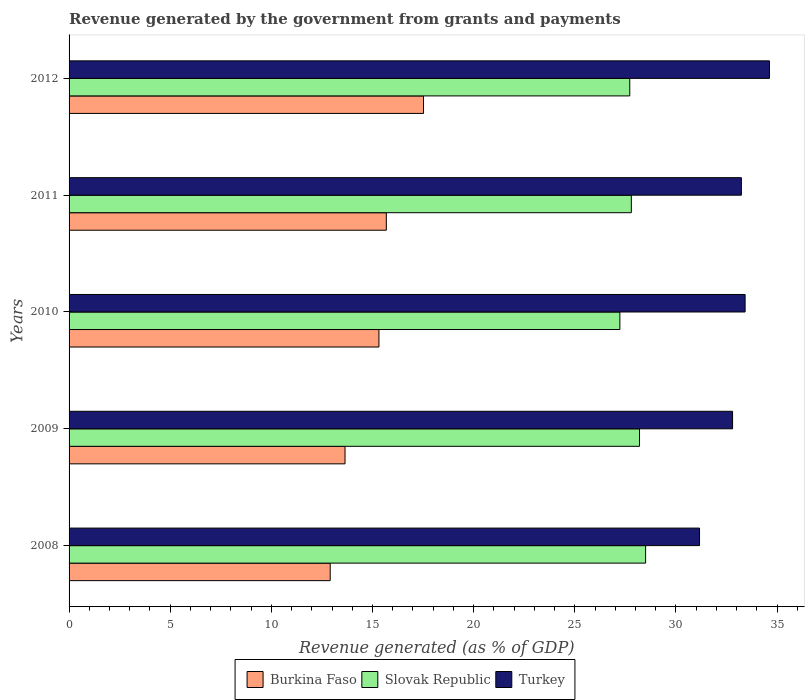How many different coloured bars are there?
Your response must be concise. 3. How many groups of bars are there?
Your answer should be compact. 5. How many bars are there on the 4th tick from the top?
Provide a succinct answer. 3. What is the label of the 4th group of bars from the top?
Your answer should be compact. 2009. In how many cases, is the number of bars for a given year not equal to the number of legend labels?
Offer a terse response. 0. What is the revenue generated by the government in Burkina Faso in 2011?
Make the answer very short. 15.68. Across all years, what is the maximum revenue generated by the government in Slovak Republic?
Offer a very short reply. 28.5. Across all years, what is the minimum revenue generated by the government in Burkina Faso?
Give a very brief answer. 12.91. In which year was the revenue generated by the government in Turkey minimum?
Make the answer very short. 2008. What is the total revenue generated by the government in Slovak Republic in the graph?
Your response must be concise. 139.44. What is the difference between the revenue generated by the government in Slovak Republic in 2008 and that in 2012?
Provide a short and direct response. 0.78. What is the difference between the revenue generated by the government in Burkina Faso in 2008 and the revenue generated by the government in Turkey in 2012?
Keep it short and to the point. -21.71. What is the average revenue generated by the government in Burkina Faso per year?
Your response must be concise. 15.01. In the year 2008, what is the difference between the revenue generated by the government in Slovak Republic and revenue generated by the government in Turkey?
Offer a very short reply. -2.67. In how many years, is the revenue generated by the government in Turkey greater than 9 %?
Give a very brief answer. 5. What is the ratio of the revenue generated by the government in Burkina Faso in 2008 to that in 2010?
Keep it short and to the point. 0.84. What is the difference between the highest and the second highest revenue generated by the government in Slovak Republic?
Your answer should be very brief. 0.3. What is the difference between the highest and the lowest revenue generated by the government in Burkina Faso?
Keep it short and to the point. 4.61. What does the 2nd bar from the top in 2011 represents?
Give a very brief answer. Slovak Republic. What does the 1st bar from the bottom in 2008 represents?
Your answer should be compact. Burkina Faso. Is it the case that in every year, the sum of the revenue generated by the government in Burkina Faso and revenue generated by the government in Turkey is greater than the revenue generated by the government in Slovak Republic?
Your answer should be very brief. Yes. Are all the bars in the graph horizontal?
Offer a very short reply. Yes. What is the difference between two consecutive major ticks on the X-axis?
Your answer should be compact. 5. Does the graph contain any zero values?
Keep it short and to the point. No. How are the legend labels stacked?
Provide a short and direct response. Horizontal. What is the title of the graph?
Your response must be concise. Revenue generated by the government from grants and payments. Does "Nepal" appear as one of the legend labels in the graph?
Your answer should be very brief. No. What is the label or title of the X-axis?
Make the answer very short. Revenue generated (as % of GDP). What is the label or title of the Y-axis?
Your answer should be compact. Years. What is the Revenue generated (as % of GDP) of Burkina Faso in 2008?
Offer a terse response. 12.91. What is the Revenue generated (as % of GDP) of Slovak Republic in 2008?
Provide a short and direct response. 28.5. What is the Revenue generated (as % of GDP) in Turkey in 2008?
Provide a short and direct response. 31.17. What is the Revenue generated (as % of GDP) in Burkina Faso in 2009?
Your response must be concise. 13.64. What is the Revenue generated (as % of GDP) of Slovak Republic in 2009?
Your answer should be very brief. 28.2. What is the Revenue generated (as % of GDP) in Turkey in 2009?
Provide a succinct answer. 32.8. What is the Revenue generated (as % of GDP) of Burkina Faso in 2010?
Provide a short and direct response. 15.32. What is the Revenue generated (as % of GDP) of Slovak Republic in 2010?
Ensure brevity in your answer.  27.23. What is the Revenue generated (as % of GDP) of Turkey in 2010?
Provide a succinct answer. 33.42. What is the Revenue generated (as % of GDP) in Burkina Faso in 2011?
Keep it short and to the point. 15.68. What is the Revenue generated (as % of GDP) in Slovak Republic in 2011?
Offer a very short reply. 27.79. What is the Revenue generated (as % of GDP) in Turkey in 2011?
Your response must be concise. 33.23. What is the Revenue generated (as % of GDP) of Burkina Faso in 2012?
Provide a short and direct response. 17.52. What is the Revenue generated (as % of GDP) of Slovak Republic in 2012?
Offer a very short reply. 27.72. What is the Revenue generated (as % of GDP) of Turkey in 2012?
Give a very brief answer. 34.62. Across all years, what is the maximum Revenue generated (as % of GDP) in Burkina Faso?
Provide a short and direct response. 17.52. Across all years, what is the maximum Revenue generated (as % of GDP) in Slovak Republic?
Your response must be concise. 28.5. Across all years, what is the maximum Revenue generated (as % of GDP) in Turkey?
Keep it short and to the point. 34.62. Across all years, what is the minimum Revenue generated (as % of GDP) of Burkina Faso?
Keep it short and to the point. 12.91. Across all years, what is the minimum Revenue generated (as % of GDP) in Slovak Republic?
Your answer should be very brief. 27.23. Across all years, what is the minimum Revenue generated (as % of GDP) in Turkey?
Keep it short and to the point. 31.17. What is the total Revenue generated (as % of GDP) in Burkina Faso in the graph?
Offer a very short reply. 75.07. What is the total Revenue generated (as % of GDP) of Slovak Republic in the graph?
Provide a succinct answer. 139.44. What is the total Revenue generated (as % of GDP) of Turkey in the graph?
Give a very brief answer. 165.24. What is the difference between the Revenue generated (as % of GDP) in Burkina Faso in 2008 and that in 2009?
Provide a succinct answer. -0.73. What is the difference between the Revenue generated (as % of GDP) in Slovak Republic in 2008 and that in 2009?
Your answer should be very brief. 0.3. What is the difference between the Revenue generated (as % of GDP) of Turkey in 2008 and that in 2009?
Make the answer very short. -1.63. What is the difference between the Revenue generated (as % of GDP) in Burkina Faso in 2008 and that in 2010?
Make the answer very short. -2.41. What is the difference between the Revenue generated (as % of GDP) of Slovak Republic in 2008 and that in 2010?
Ensure brevity in your answer.  1.27. What is the difference between the Revenue generated (as % of GDP) in Turkey in 2008 and that in 2010?
Offer a very short reply. -2.25. What is the difference between the Revenue generated (as % of GDP) of Burkina Faso in 2008 and that in 2011?
Provide a succinct answer. -2.77. What is the difference between the Revenue generated (as % of GDP) in Slovak Republic in 2008 and that in 2011?
Your answer should be very brief. 0.71. What is the difference between the Revenue generated (as % of GDP) of Turkey in 2008 and that in 2011?
Provide a succinct answer. -2.07. What is the difference between the Revenue generated (as % of GDP) in Burkina Faso in 2008 and that in 2012?
Offer a very short reply. -4.61. What is the difference between the Revenue generated (as % of GDP) of Slovak Republic in 2008 and that in 2012?
Your answer should be very brief. 0.78. What is the difference between the Revenue generated (as % of GDP) of Turkey in 2008 and that in 2012?
Ensure brevity in your answer.  -3.46. What is the difference between the Revenue generated (as % of GDP) in Burkina Faso in 2009 and that in 2010?
Give a very brief answer. -1.68. What is the difference between the Revenue generated (as % of GDP) in Slovak Republic in 2009 and that in 2010?
Your answer should be compact. 0.97. What is the difference between the Revenue generated (as % of GDP) of Turkey in 2009 and that in 2010?
Your answer should be compact. -0.62. What is the difference between the Revenue generated (as % of GDP) of Burkina Faso in 2009 and that in 2011?
Your answer should be compact. -2.04. What is the difference between the Revenue generated (as % of GDP) of Slovak Republic in 2009 and that in 2011?
Offer a terse response. 0.41. What is the difference between the Revenue generated (as % of GDP) of Turkey in 2009 and that in 2011?
Provide a short and direct response. -0.44. What is the difference between the Revenue generated (as % of GDP) in Burkina Faso in 2009 and that in 2012?
Your answer should be very brief. -3.88. What is the difference between the Revenue generated (as % of GDP) of Slovak Republic in 2009 and that in 2012?
Offer a terse response. 0.48. What is the difference between the Revenue generated (as % of GDP) in Turkey in 2009 and that in 2012?
Make the answer very short. -1.82. What is the difference between the Revenue generated (as % of GDP) in Burkina Faso in 2010 and that in 2011?
Give a very brief answer. -0.37. What is the difference between the Revenue generated (as % of GDP) in Slovak Republic in 2010 and that in 2011?
Offer a very short reply. -0.57. What is the difference between the Revenue generated (as % of GDP) in Turkey in 2010 and that in 2011?
Provide a short and direct response. 0.18. What is the difference between the Revenue generated (as % of GDP) of Burkina Faso in 2010 and that in 2012?
Keep it short and to the point. -2.2. What is the difference between the Revenue generated (as % of GDP) of Slovak Republic in 2010 and that in 2012?
Provide a short and direct response. -0.49. What is the difference between the Revenue generated (as % of GDP) in Turkey in 2010 and that in 2012?
Make the answer very short. -1.2. What is the difference between the Revenue generated (as % of GDP) of Burkina Faso in 2011 and that in 2012?
Your answer should be very brief. -1.84. What is the difference between the Revenue generated (as % of GDP) in Slovak Republic in 2011 and that in 2012?
Your answer should be compact. 0.08. What is the difference between the Revenue generated (as % of GDP) in Turkey in 2011 and that in 2012?
Offer a very short reply. -1.39. What is the difference between the Revenue generated (as % of GDP) of Burkina Faso in 2008 and the Revenue generated (as % of GDP) of Slovak Republic in 2009?
Provide a succinct answer. -15.29. What is the difference between the Revenue generated (as % of GDP) in Burkina Faso in 2008 and the Revenue generated (as % of GDP) in Turkey in 2009?
Your response must be concise. -19.89. What is the difference between the Revenue generated (as % of GDP) in Slovak Republic in 2008 and the Revenue generated (as % of GDP) in Turkey in 2009?
Give a very brief answer. -4.3. What is the difference between the Revenue generated (as % of GDP) in Burkina Faso in 2008 and the Revenue generated (as % of GDP) in Slovak Republic in 2010?
Your answer should be compact. -14.32. What is the difference between the Revenue generated (as % of GDP) of Burkina Faso in 2008 and the Revenue generated (as % of GDP) of Turkey in 2010?
Ensure brevity in your answer.  -20.51. What is the difference between the Revenue generated (as % of GDP) of Slovak Republic in 2008 and the Revenue generated (as % of GDP) of Turkey in 2010?
Your answer should be very brief. -4.92. What is the difference between the Revenue generated (as % of GDP) of Burkina Faso in 2008 and the Revenue generated (as % of GDP) of Slovak Republic in 2011?
Your answer should be very brief. -14.89. What is the difference between the Revenue generated (as % of GDP) in Burkina Faso in 2008 and the Revenue generated (as % of GDP) in Turkey in 2011?
Your response must be concise. -20.33. What is the difference between the Revenue generated (as % of GDP) of Slovak Republic in 2008 and the Revenue generated (as % of GDP) of Turkey in 2011?
Your response must be concise. -4.73. What is the difference between the Revenue generated (as % of GDP) in Burkina Faso in 2008 and the Revenue generated (as % of GDP) in Slovak Republic in 2012?
Offer a very short reply. -14.81. What is the difference between the Revenue generated (as % of GDP) of Burkina Faso in 2008 and the Revenue generated (as % of GDP) of Turkey in 2012?
Give a very brief answer. -21.71. What is the difference between the Revenue generated (as % of GDP) in Slovak Republic in 2008 and the Revenue generated (as % of GDP) in Turkey in 2012?
Keep it short and to the point. -6.12. What is the difference between the Revenue generated (as % of GDP) in Burkina Faso in 2009 and the Revenue generated (as % of GDP) in Slovak Republic in 2010?
Keep it short and to the point. -13.59. What is the difference between the Revenue generated (as % of GDP) in Burkina Faso in 2009 and the Revenue generated (as % of GDP) in Turkey in 2010?
Give a very brief answer. -19.78. What is the difference between the Revenue generated (as % of GDP) of Slovak Republic in 2009 and the Revenue generated (as % of GDP) of Turkey in 2010?
Provide a short and direct response. -5.22. What is the difference between the Revenue generated (as % of GDP) of Burkina Faso in 2009 and the Revenue generated (as % of GDP) of Slovak Republic in 2011?
Provide a short and direct response. -14.15. What is the difference between the Revenue generated (as % of GDP) in Burkina Faso in 2009 and the Revenue generated (as % of GDP) in Turkey in 2011?
Offer a very short reply. -19.59. What is the difference between the Revenue generated (as % of GDP) in Slovak Republic in 2009 and the Revenue generated (as % of GDP) in Turkey in 2011?
Ensure brevity in your answer.  -5.04. What is the difference between the Revenue generated (as % of GDP) in Burkina Faso in 2009 and the Revenue generated (as % of GDP) in Slovak Republic in 2012?
Give a very brief answer. -14.08. What is the difference between the Revenue generated (as % of GDP) in Burkina Faso in 2009 and the Revenue generated (as % of GDP) in Turkey in 2012?
Your answer should be very brief. -20.98. What is the difference between the Revenue generated (as % of GDP) in Slovak Republic in 2009 and the Revenue generated (as % of GDP) in Turkey in 2012?
Make the answer very short. -6.42. What is the difference between the Revenue generated (as % of GDP) of Burkina Faso in 2010 and the Revenue generated (as % of GDP) of Slovak Republic in 2011?
Make the answer very short. -12.48. What is the difference between the Revenue generated (as % of GDP) of Burkina Faso in 2010 and the Revenue generated (as % of GDP) of Turkey in 2011?
Offer a terse response. -17.92. What is the difference between the Revenue generated (as % of GDP) of Slovak Republic in 2010 and the Revenue generated (as % of GDP) of Turkey in 2011?
Your response must be concise. -6.01. What is the difference between the Revenue generated (as % of GDP) of Burkina Faso in 2010 and the Revenue generated (as % of GDP) of Slovak Republic in 2012?
Ensure brevity in your answer.  -12.4. What is the difference between the Revenue generated (as % of GDP) in Burkina Faso in 2010 and the Revenue generated (as % of GDP) in Turkey in 2012?
Keep it short and to the point. -19.31. What is the difference between the Revenue generated (as % of GDP) in Slovak Republic in 2010 and the Revenue generated (as % of GDP) in Turkey in 2012?
Give a very brief answer. -7.39. What is the difference between the Revenue generated (as % of GDP) of Burkina Faso in 2011 and the Revenue generated (as % of GDP) of Slovak Republic in 2012?
Keep it short and to the point. -12.03. What is the difference between the Revenue generated (as % of GDP) in Burkina Faso in 2011 and the Revenue generated (as % of GDP) in Turkey in 2012?
Ensure brevity in your answer.  -18.94. What is the difference between the Revenue generated (as % of GDP) of Slovak Republic in 2011 and the Revenue generated (as % of GDP) of Turkey in 2012?
Ensure brevity in your answer.  -6.83. What is the average Revenue generated (as % of GDP) in Burkina Faso per year?
Make the answer very short. 15.01. What is the average Revenue generated (as % of GDP) of Slovak Republic per year?
Keep it short and to the point. 27.89. What is the average Revenue generated (as % of GDP) in Turkey per year?
Your response must be concise. 33.05. In the year 2008, what is the difference between the Revenue generated (as % of GDP) in Burkina Faso and Revenue generated (as % of GDP) in Slovak Republic?
Your answer should be very brief. -15.59. In the year 2008, what is the difference between the Revenue generated (as % of GDP) of Burkina Faso and Revenue generated (as % of GDP) of Turkey?
Your answer should be very brief. -18.26. In the year 2008, what is the difference between the Revenue generated (as % of GDP) of Slovak Republic and Revenue generated (as % of GDP) of Turkey?
Offer a very short reply. -2.67. In the year 2009, what is the difference between the Revenue generated (as % of GDP) in Burkina Faso and Revenue generated (as % of GDP) in Slovak Republic?
Offer a very short reply. -14.56. In the year 2009, what is the difference between the Revenue generated (as % of GDP) in Burkina Faso and Revenue generated (as % of GDP) in Turkey?
Give a very brief answer. -19.16. In the year 2009, what is the difference between the Revenue generated (as % of GDP) in Slovak Republic and Revenue generated (as % of GDP) in Turkey?
Provide a short and direct response. -4.6. In the year 2010, what is the difference between the Revenue generated (as % of GDP) in Burkina Faso and Revenue generated (as % of GDP) in Slovak Republic?
Offer a terse response. -11.91. In the year 2010, what is the difference between the Revenue generated (as % of GDP) in Burkina Faso and Revenue generated (as % of GDP) in Turkey?
Give a very brief answer. -18.1. In the year 2010, what is the difference between the Revenue generated (as % of GDP) of Slovak Republic and Revenue generated (as % of GDP) of Turkey?
Offer a very short reply. -6.19. In the year 2011, what is the difference between the Revenue generated (as % of GDP) of Burkina Faso and Revenue generated (as % of GDP) of Slovak Republic?
Ensure brevity in your answer.  -12.11. In the year 2011, what is the difference between the Revenue generated (as % of GDP) of Burkina Faso and Revenue generated (as % of GDP) of Turkey?
Offer a terse response. -17.55. In the year 2011, what is the difference between the Revenue generated (as % of GDP) in Slovak Republic and Revenue generated (as % of GDP) in Turkey?
Your answer should be very brief. -5.44. In the year 2012, what is the difference between the Revenue generated (as % of GDP) in Burkina Faso and Revenue generated (as % of GDP) in Slovak Republic?
Provide a short and direct response. -10.2. In the year 2012, what is the difference between the Revenue generated (as % of GDP) in Burkina Faso and Revenue generated (as % of GDP) in Turkey?
Your answer should be compact. -17.1. In the year 2012, what is the difference between the Revenue generated (as % of GDP) in Slovak Republic and Revenue generated (as % of GDP) in Turkey?
Your response must be concise. -6.91. What is the ratio of the Revenue generated (as % of GDP) in Burkina Faso in 2008 to that in 2009?
Offer a very short reply. 0.95. What is the ratio of the Revenue generated (as % of GDP) in Slovak Republic in 2008 to that in 2009?
Ensure brevity in your answer.  1.01. What is the ratio of the Revenue generated (as % of GDP) in Turkey in 2008 to that in 2009?
Provide a succinct answer. 0.95. What is the ratio of the Revenue generated (as % of GDP) in Burkina Faso in 2008 to that in 2010?
Your response must be concise. 0.84. What is the ratio of the Revenue generated (as % of GDP) in Slovak Republic in 2008 to that in 2010?
Your response must be concise. 1.05. What is the ratio of the Revenue generated (as % of GDP) in Turkey in 2008 to that in 2010?
Your answer should be compact. 0.93. What is the ratio of the Revenue generated (as % of GDP) in Burkina Faso in 2008 to that in 2011?
Your answer should be very brief. 0.82. What is the ratio of the Revenue generated (as % of GDP) in Slovak Republic in 2008 to that in 2011?
Provide a short and direct response. 1.03. What is the ratio of the Revenue generated (as % of GDP) of Turkey in 2008 to that in 2011?
Your answer should be compact. 0.94. What is the ratio of the Revenue generated (as % of GDP) of Burkina Faso in 2008 to that in 2012?
Make the answer very short. 0.74. What is the ratio of the Revenue generated (as % of GDP) in Slovak Republic in 2008 to that in 2012?
Provide a succinct answer. 1.03. What is the ratio of the Revenue generated (as % of GDP) of Turkey in 2008 to that in 2012?
Make the answer very short. 0.9. What is the ratio of the Revenue generated (as % of GDP) of Burkina Faso in 2009 to that in 2010?
Make the answer very short. 0.89. What is the ratio of the Revenue generated (as % of GDP) in Slovak Republic in 2009 to that in 2010?
Provide a short and direct response. 1.04. What is the ratio of the Revenue generated (as % of GDP) in Turkey in 2009 to that in 2010?
Make the answer very short. 0.98. What is the ratio of the Revenue generated (as % of GDP) of Burkina Faso in 2009 to that in 2011?
Provide a succinct answer. 0.87. What is the ratio of the Revenue generated (as % of GDP) of Slovak Republic in 2009 to that in 2011?
Offer a terse response. 1.01. What is the ratio of the Revenue generated (as % of GDP) of Turkey in 2009 to that in 2011?
Ensure brevity in your answer.  0.99. What is the ratio of the Revenue generated (as % of GDP) in Burkina Faso in 2009 to that in 2012?
Your answer should be very brief. 0.78. What is the ratio of the Revenue generated (as % of GDP) of Slovak Republic in 2009 to that in 2012?
Give a very brief answer. 1.02. What is the ratio of the Revenue generated (as % of GDP) in Turkey in 2009 to that in 2012?
Provide a short and direct response. 0.95. What is the ratio of the Revenue generated (as % of GDP) in Burkina Faso in 2010 to that in 2011?
Keep it short and to the point. 0.98. What is the ratio of the Revenue generated (as % of GDP) in Slovak Republic in 2010 to that in 2011?
Provide a succinct answer. 0.98. What is the ratio of the Revenue generated (as % of GDP) in Turkey in 2010 to that in 2011?
Keep it short and to the point. 1.01. What is the ratio of the Revenue generated (as % of GDP) of Burkina Faso in 2010 to that in 2012?
Provide a short and direct response. 0.87. What is the ratio of the Revenue generated (as % of GDP) in Slovak Republic in 2010 to that in 2012?
Ensure brevity in your answer.  0.98. What is the ratio of the Revenue generated (as % of GDP) of Turkey in 2010 to that in 2012?
Your response must be concise. 0.97. What is the ratio of the Revenue generated (as % of GDP) in Burkina Faso in 2011 to that in 2012?
Your answer should be very brief. 0.9. What is the ratio of the Revenue generated (as % of GDP) of Turkey in 2011 to that in 2012?
Offer a terse response. 0.96. What is the difference between the highest and the second highest Revenue generated (as % of GDP) of Burkina Faso?
Your answer should be compact. 1.84. What is the difference between the highest and the second highest Revenue generated (as % of GDP) of Slovak Republic?
Your answer should be compact. 0.3. What is the difference between the highest and the second highest Revenue generated (as % of GDP) in Turkey?
Make the answer very short. 1.2. What is the difference between the highest and the lowest Revenue generated (as % of GDP) of Burkina Faso?
Keep it short and to the point. 4.61. What is the difference between the highest and the lowest Revenue generated (as % of GDP) in Slovak Republic?
Your response must be concise. 1.27. What is the difference between the highest and the lowest Revenue generated (as % of GDP) of Turkey?
Ensure brevity in your answer.  3.46. 